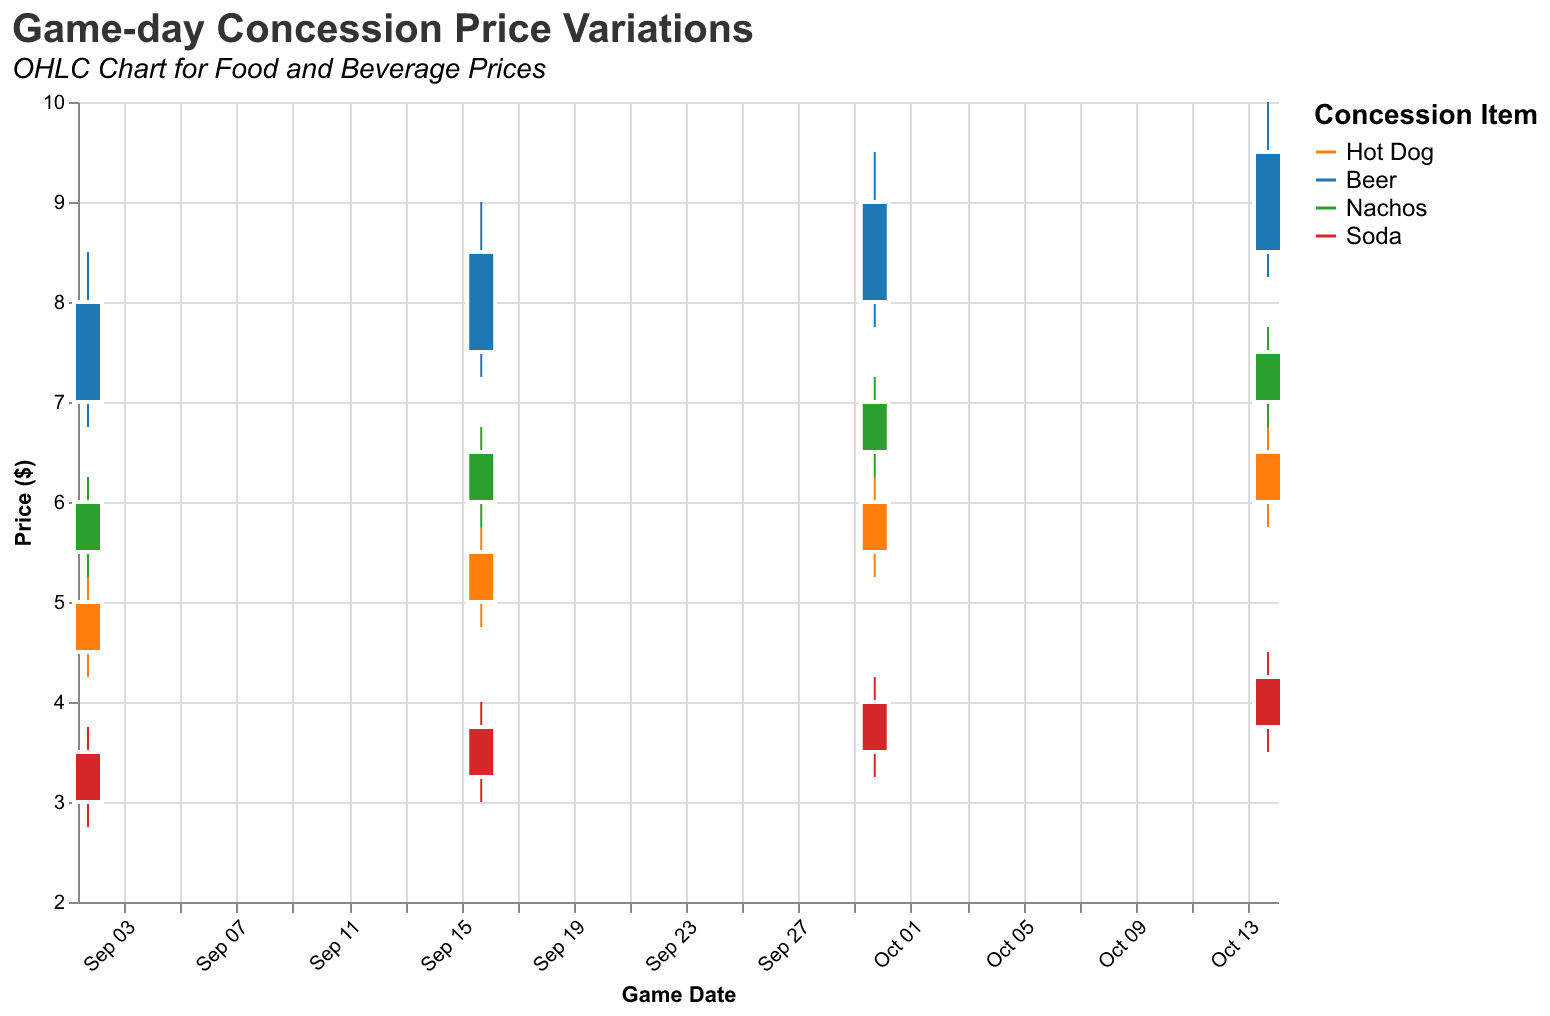What does the chart title suggest? The title of the chart is "Game-day Concession Price Variations," with a subtitle "OHLC Chart for Food and Beverage Prices." This indicates that the chart will show the variations in prices of food and beverage items sold on game days.
Answer: Price variations for game-day concessions What is the highest price for Beer recorded in the chart? Looking at the OHLC bars for Beer, the highest price is on October 14, which is 10.00 dollars.
Answer: 10.00 dollars Which item shows the greatest price variation on September 02? On September 02, the price range (High-Low) for Hot Dog is (5.25-4.25)=1.00, for Beer is (8.50-6.75)=1.75, for Nachos is (6.25-5.25)=1.00, and for Soda is (3.75-2.75)=1.00. Therefore, Beer shows the greatest price variation.
Answer: Beer What is the closing price of Soda on October 14? Referring to the OHLC bar for Soda on October 14, the closing price is indicated at 4.25 dollars.
Answer: 4.25 dollars How do the opening prices of Hot Dog compare from September 02 to October 14? The opening prices of Hot Dog are 4.50 on September 02, 5.00 on September 16, 5.50 on September 30, and 6.00 on October 14. The price has increased gradually over the dates.
Answer: Gradually increased Which item had the lowest price on September 30? Reviewing the OHLC data for September 30, Soda has the lowest price with a Low value of 3.25 dollars.
Answer: Soda What is the average closing price of Nachos across all dates? The closing prices for Nachos are 6.00, 6.50, 7.00, and 7.50. Summing them gives (6.00 + 6.50 + 7.00 + 7.50) = 27.00, divided by 4 dates is 27.00/4 = 6.75 dollars.
Answer: 6.75 dollars Comparing items on October 14, which had the smallest range between High and Low prices? For October 14, the ranges are calculated as follows: Hot Dog (6.75-5.75)=1.00, Beer (10.00-8.25)=1.75, Nachos (7.75-6.75)=1.00, Soda (4.50-3.50)=1.00. The smallest range is shared by Hot Dog, Nachos, and Soda.
Answer: Hot Dog, Nachos, and Soda What is the total high price for Beer across all dates? Summing the highest prices for Beer on each date: 8.50 + 9.00 + 9.50 + 10.00, giving a total of 37.00 dollars.
Answer: 37.00 dollars Did the price of a Hot Dog ever decrease between any two game dates? Reviewing the closing prices: 5.00 on Sep 02, 5.50 on Sep 16, 6.00 on Sep 30, and 6.50 on Oct 14, the price consistently increased and never decreased.
Answer: No 